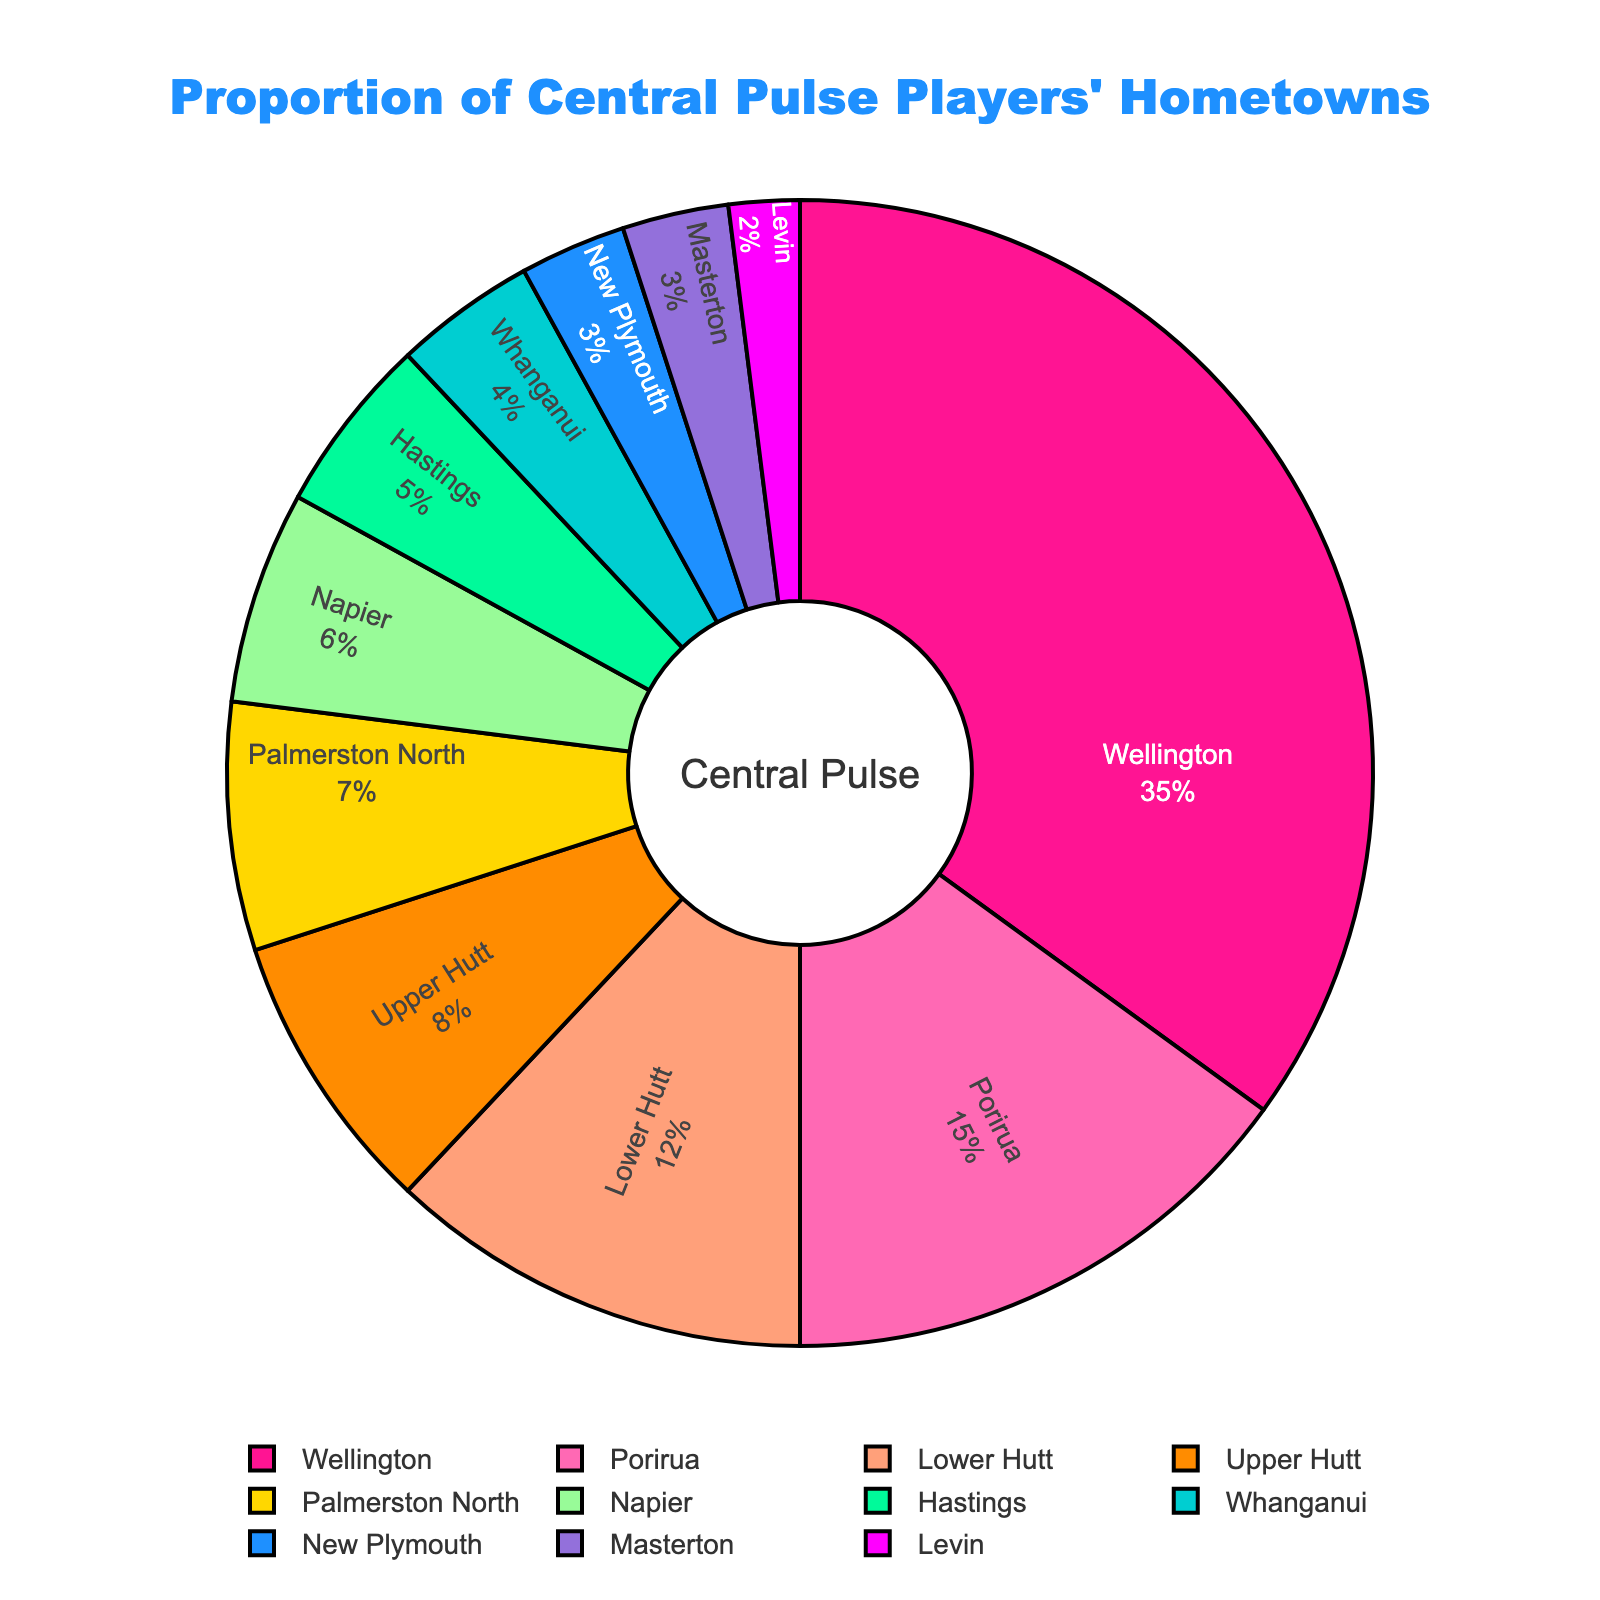Which hometown has the highest proportion of players? The label with the largest percentage is Wellington, which has 35%.
Answer: Wellington What's the combined percentage of players from Porirua and Napier? Porirua has 15% and Napier has 6%. Adding them together gives 15% + 6% = 21%.
Answer: 21% How many more percentage points do Wellington players have compared to Lower Hutt players? Wellington has 35% and Lower Hutt has 12%. The difference is 35% - 12% = 23%.
Answer: 23% Which hometowns have a percentage of players less than 5%? The labels with percentages less than 5% are Whanganui (4%), New Plymouth (3%), Masterton (3%), and Levin (2%).
Answer: Whanganui, New Plymouth, Masterton, Levin Which two hometowns combined make up exactly 10% of the players? Upper Hutt has 8% and Levin has 2%, adding them together gives 8% + 2% = 10%.
Answer: Upper Hutt and Levin What is the percentage difference between Palmerston North and Hastings? Palmerston North has 7% and Hastings has 5%. The difference is 7% - 5% = 2%.
Answer: 2% Is the combined percentage of the three smallest segments greater than 10%? The three smallest percentages are Levin (2%), New Plymouth (3%), and Masterton (3%). Adding them together gives 2% + 3% + 3% = 8%, which is less than 10%.
Answer: No What is the average percentage of players from the top three hometowns? The top three percentages are Wellington (35%), Porirua (15%), and Lower Hutt (12%). The average is (35% + 15% + 12%) / 3 = 62% / 3 = 20.67%.
Answer: 20.67% Which section is colored red? The segments are colored uniquely and Wellington has the highest percentage displayed prominently, colored red in the chart.
Answer: Wellington What percentage of players come from Wellington compared to the total percentage of players from Lower Hutt and Upper Hutt combined? Wellington has 35%, Lower Hutt has 12%, and Upper Hutt has 8%. The combined percentage for Lower Hutt and Upper Hutt is 12% + 8% = 20%. Comparing, 35% is 15 percentage points more than 20%.
Answer: 15% more 